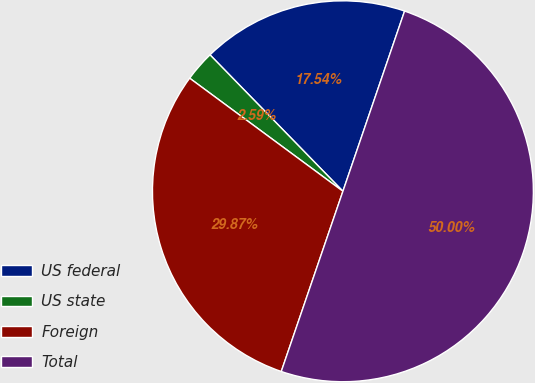Convert chart to OTSL. <chart><loc_0><loc_0><loc_500><loc_500><pie_chart><fcel>US federal<fcel>US state<fcel>Foreign<fcel>Total<nl><fcel>17.54%<fcel>2.59%<fcel>29.87%<fcel>50.0%<nl></chart> 